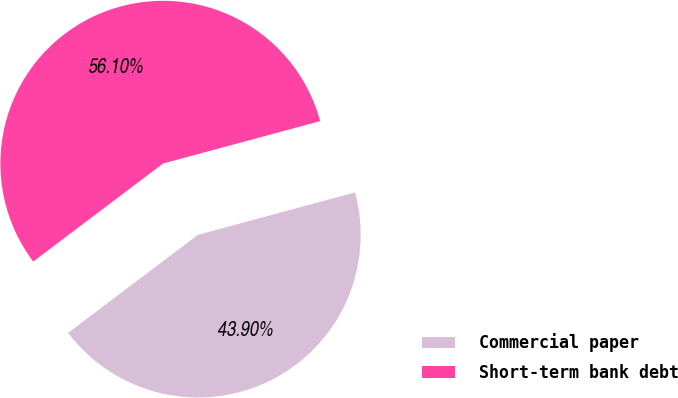Convert chart. <chart><loc_0><loc_0><loc_500><loc_500><pie_chart><fcel>Commercial paper<fcel>Short-term bank debt<nl><fcel>43.9%<fcel>56.1%<nl></chart> 